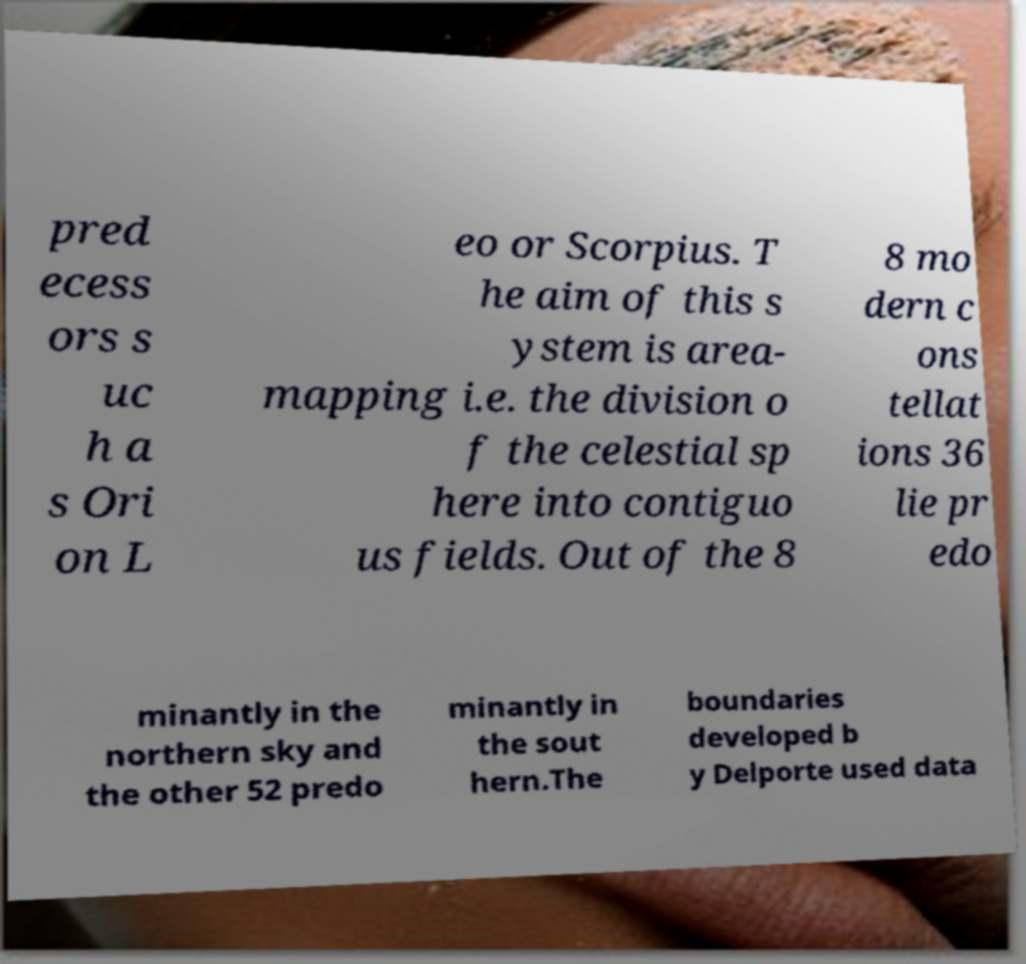There's text embedded in this image that I need extracted. Can you transcribe it verbatim? pred ecess ors s uc h a s Ori on L eo or Scorpius. T he aim of this s ystem is area- mapping i.e. the division o f the celestial sp here into contiguo us fields. Out of the 8 8 mo dern c ons tellat ions 36 lie pr edo minantly in the northern sky and the other 52 predo minantly in the sout hern.The boundaries developed b y Delporte used data 